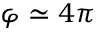<formula> <loc_0><loc_0><loc_500><loc_500>\varphi \simeq 4 \pi</formula> 